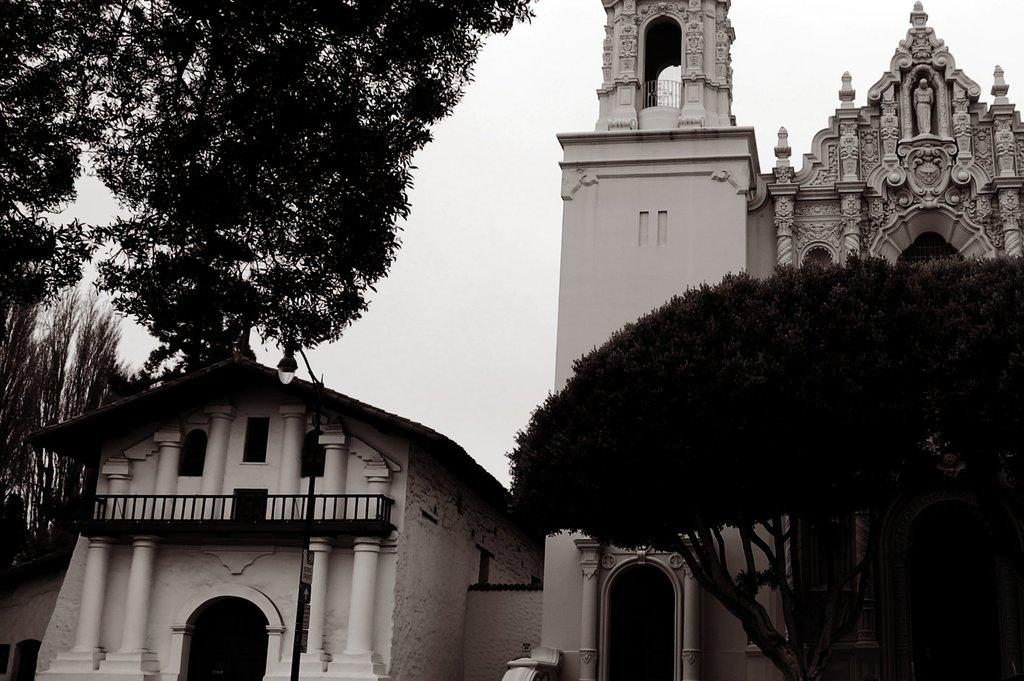What type of structures can be seen in the image? There are buildings in the image. What natural elements are present in the image? There are trees in the image. What architectural features can be observed in the image? There are pillars in the image. What other objects can be seen in the image? There is a pole, a light, and boards in the image. What is visible in the background of the image? The sky is visible in the background of the image. What type of ink is being used to draw on the boards in the image? There is no ink or drawing activity present in the image; it features buildings, trees, pillars, a pole, a light, and boards. Can you tell me how many roses are on the pole in the image? There are no roses present in the image; it features buildings, trees, pillars, a pole, a light, and boards. 